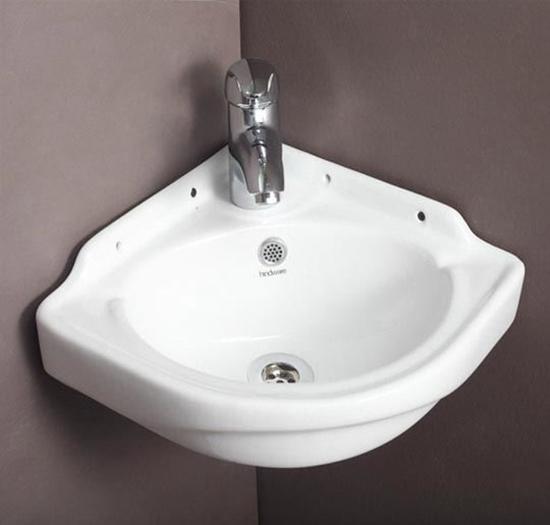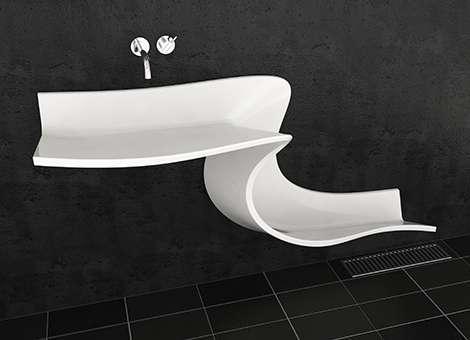The first image is the image on the left, the second image is the image on the right. Given the left and right images, does the statement "At least one sink is sitting on a counter." hold true? Answer yes or no. No. 